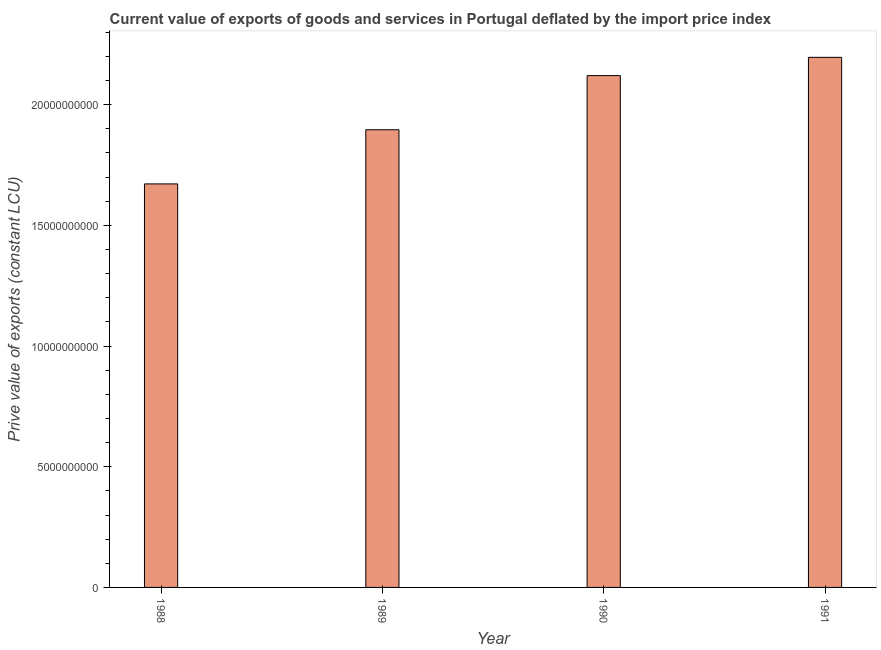Does the graph contain any zero values?
Keep it short and to the point. No. What is the title of the graph?
Your answer should be compact. Current value of exports of goods and services in Portugal deflated by the import price index. What is the label or title of the X-axis?
Provide a succinct answer. Year. What is the label or title of the Y-axis?
Provide a short and direct response. Prive value of exports (constant LCU). What is the price value of exports in 1988?
Your answer should be very brief. 1.67e+1. Across all years, what is the maximum price value of exports?
Your response must be concise. 2.20e+1. Across all years, what is the minimum price value of exports?
Provide a short and direct response. 1.67e+1. In which year was the price value of exports minimum?
Ensure brevity in your answer.  1988. What is the sum of the price value of exports?
Give a very brief answer. 7.88e+1. What is the difference between the price value of exports in 1988 and 1990?
Your response must be concise. -4.49e+09. What is the average price value of exports per year?
Ensure brevity in your answer.  1.97e+1. What is the median price value of exports?
Ensure brevity in your answer.  2.01e+1. Do a majority of the years between 1988 and 1989 (inclusive) have price value of exports greater than 6000000000 LCU?
Provide a succinct answer. Yes. What is the ratio of the price value of exports in 1989 to that in 1990?
Offer a very short reply. 0.89. Is the difference between the price value of exports in 1988 and 1990 greater than the difference between any two years?
Provide a short and direct response. No. What is the difference between the highest and the second highest price value of exports?
Provide a succinct answer. 7.57e+08. What is the difference between the highest and the lowest price value of exports?
Make the answer very short. 5.24e+09. Are all the bars in the graph horizontal?
Your answer should be compact. No. Are the values on the major ticks of Y-axis written in scientific E-notation?
Offer a terse response. No. What is the Prive value of exports (constant LCU) in 1988?
Ensure brevity in your answer.  1.67e+1. What is the Prive value of exports (constant LCU) of 1989?
Offer a terse response. 1.90e+1. What is the Prive value of exports (constant LCU) in 1990?
Offer a terse response. 2.12e+1. What is the Prive value of exports (constant LCU) of 1991?
Your answer should be compact. 2.20e+1. What is the difference between the Prive value of exports (constant LCU) in 1988 and 1989?
Ensure brevity in your answer.  -2.24e+09. What is the difference between the Prive value of exports (constant LCU) in 1988 and 1990?
Your response must be concise. -4.49e+09. What is the difference between the Prive value of exports (constant LCU) in 1988 and 1991?
Ensure brevity in your answer.  -5.24e+09. What is the difference between the Prive value of exports (constant LCU) in 1989 and 1990?
Keep it short and to the point. -2.24e+09. What is the difference between the Prive value of exports (constant LCU) in 1989 and 1991?
Ensure brevity in your answer.  -3.00e+09. What is the difference between the Prive value of exports (constant LCU) in 1990 and 1991?
Provide a short and direct response. -7.57e+08. What is the ratio of the Prive value of exports (constant LCU) in 1988 to that in 1989?
Keep it short and to the point. 0.88. What is the ratio of the Prive value of exports (constant LCU) in 1988 to that in 1990?
Give a very brief answer. 0.79. What is the ratio of the Prive value of exports (constant LCU) in 1988 to that in 1991?
Your answer should be very brief. 0.76. What is the ratio of the Prive value of exports (constant LCU) in 1989 to that in 1990?
Your answer should be compact. 0.89. What is the ratio of the Prive value of exports (constant LCU) in 1989 to that in 1991?
Ensure brevity in your answer.  0.86. What is the ratio of the Prive value of exports (constant LCU) in 1990 to that in 1991?
Provide a short and direct response. 0.97. 